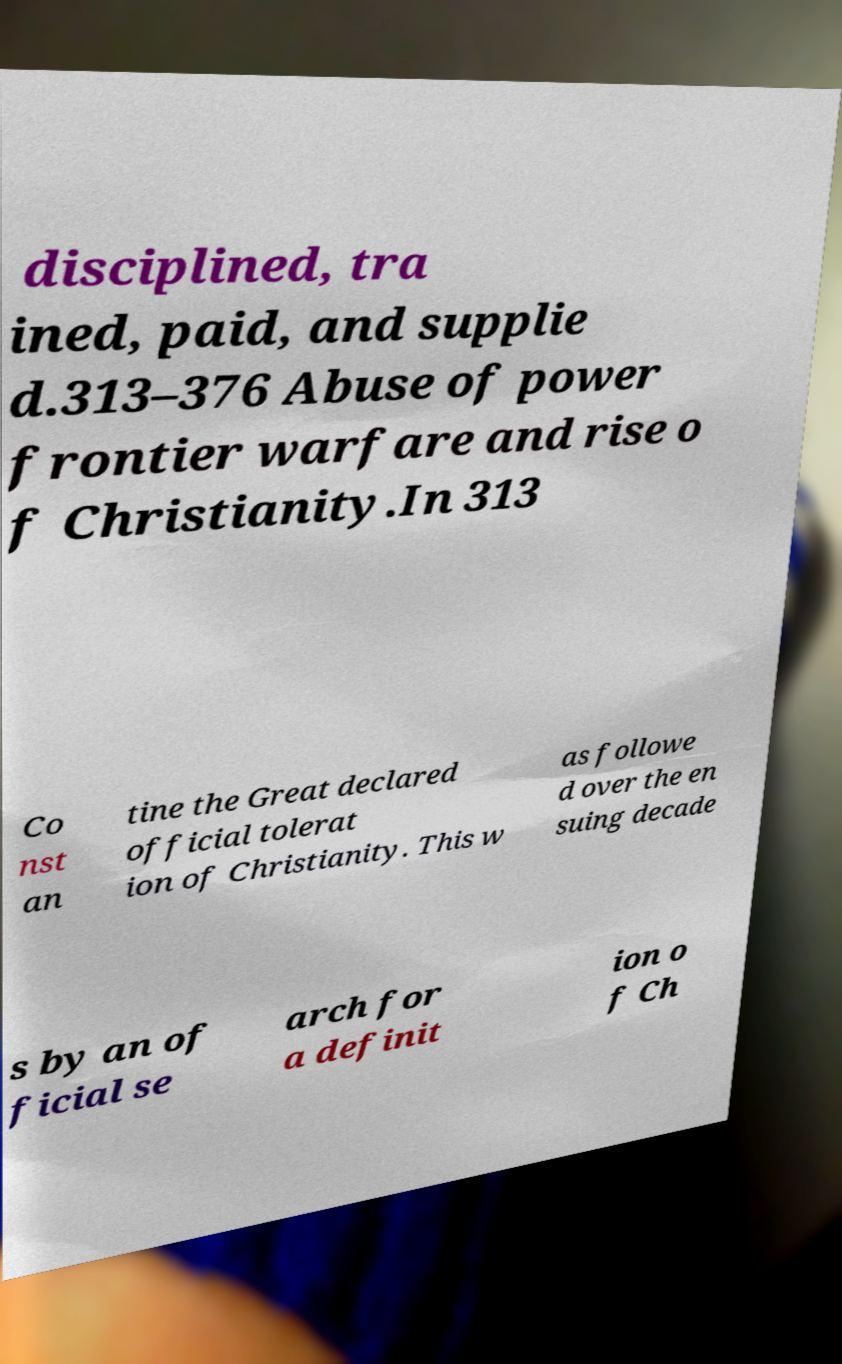Can you read and provide the text displayed in the image?This photo seems to have some interesting text. Can you extract and type it out for me? disciplined, tra ined, paid, and supplie d.313–376 Abuse of power frontier warfare and rise o f Christianity.In 313 Co nst an tine the Great declared official tolerat ion of Christianity. This w as followe d over the en suing decade s by an of ficial se arch for a definit ion o f Ch 